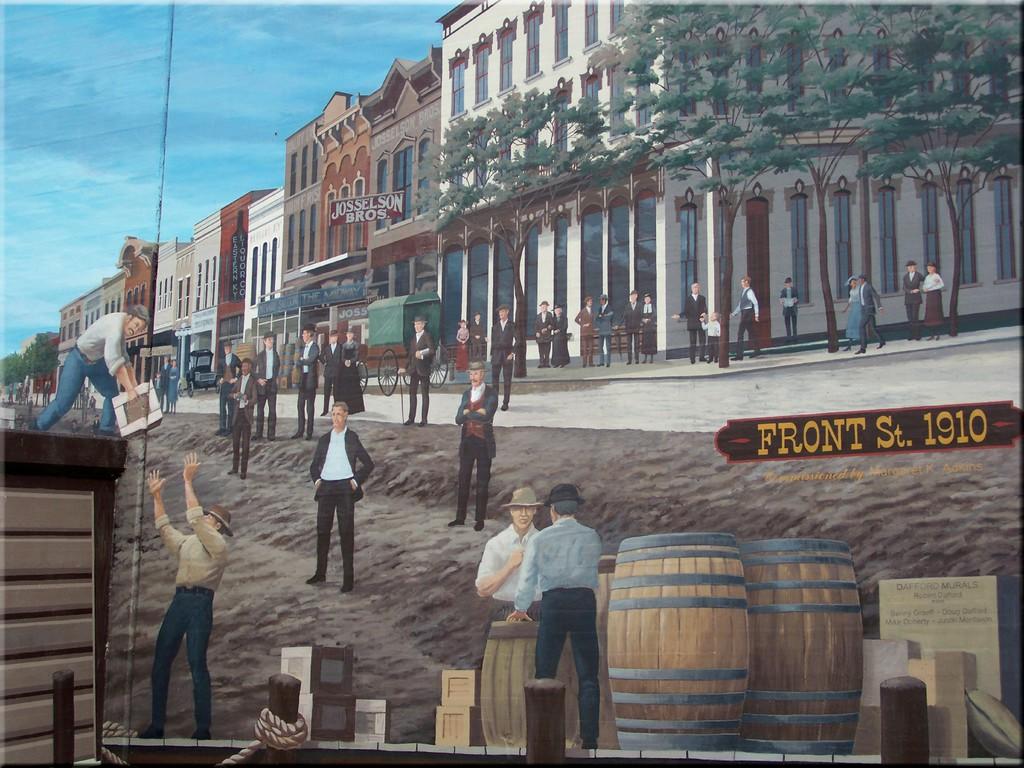What street are the people standing on?
Make the answer very short. Front st. Is that sign in the background for josselson bros.?
Your response must be concise. Yes. 